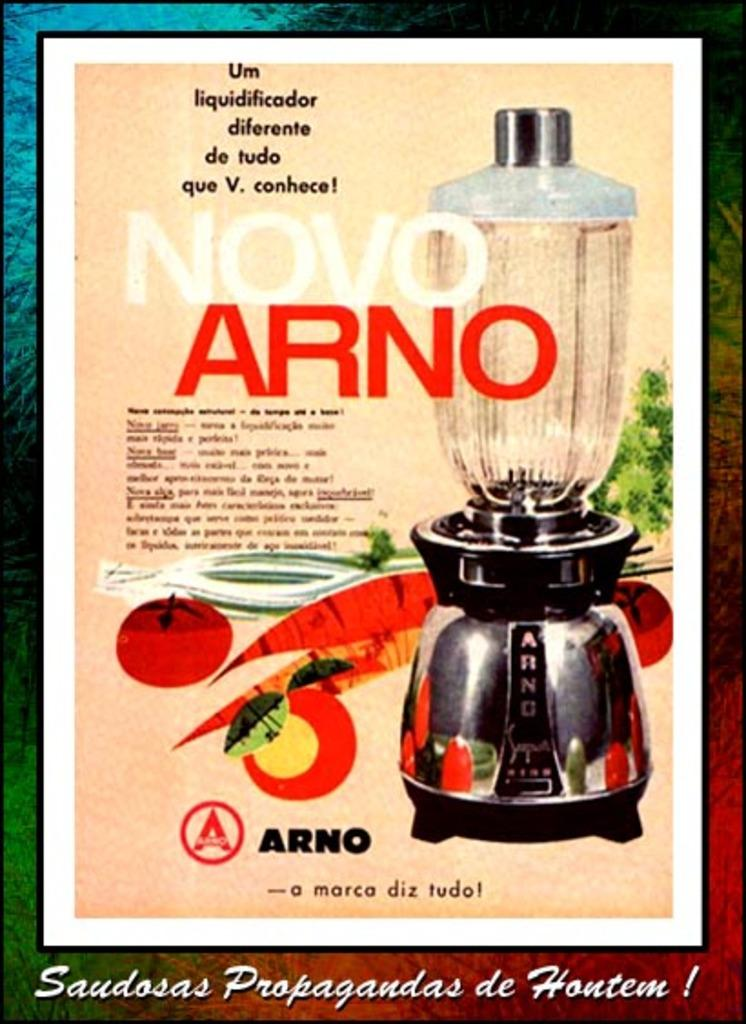<image>
Share a concise interpretation of the image provided. An advertisement for an Arno blender with pictures of fruit and vegetables on it. 